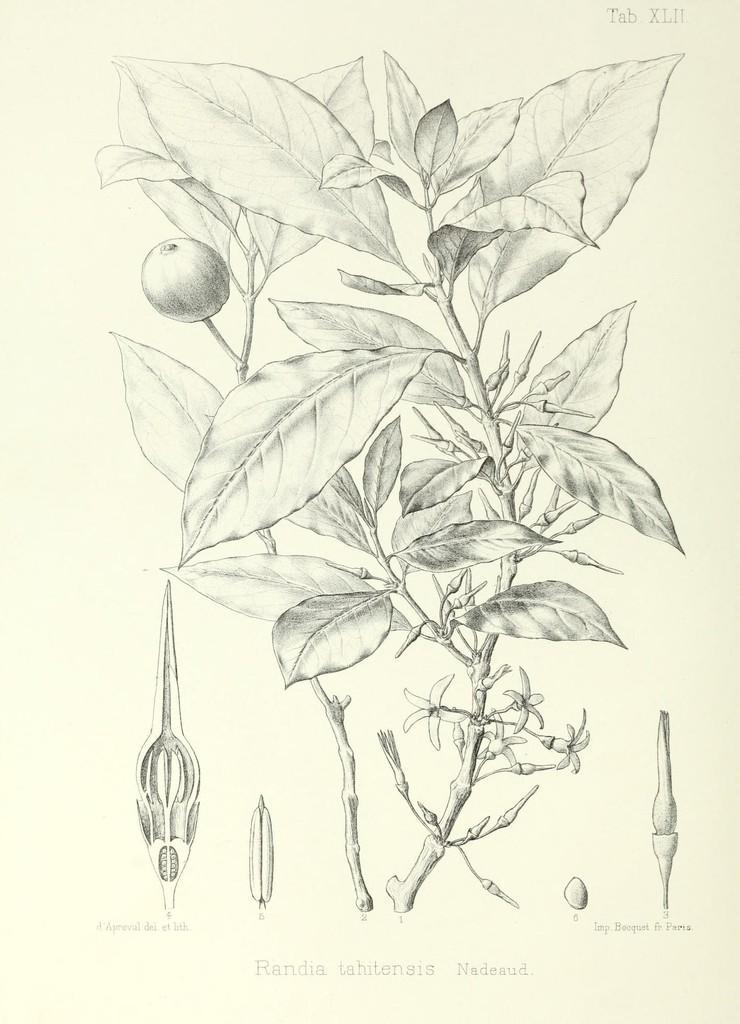Could you give a brief overview of what you see in this image? This is a drawing, in this image there is a plant and on the right side and left side there are some parts of plants are drawn and there is a text. 